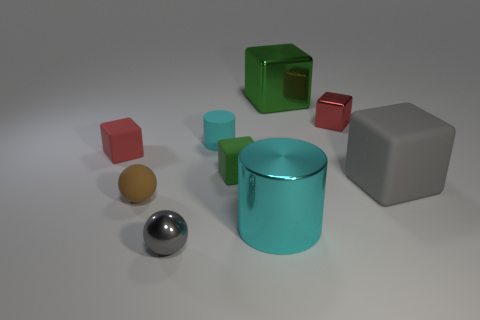There is a tiny shiny thing that is the same color as the big rubber object; what is its shape?
Make the answer very short. Sphere. What number of things are big cyan metallic cylinders or cyan cylinders in front of the small brown object?
Your answer should be compact. 1. What is the tiny cylinder made of?
Your answer should be very brief. Rubber. Are there any other things that are the same color as the large matte block?
Offer a very short reply. Yes. Does the red matte object have the same shape as the big green thing?
Ensure brevity in your answer.  Yes. What is the size of the cylinder behind the gray object that is right of the object that is in front of the cyan shiny cylinder?
Make the answer very short. Small. How many other objects are there of the same material as the big cyan object?
Your answer should be compact. 3. There is a metallic block that is behind the small metal cube; what is its color?
Keep it short and to the point. Green. There is a thing that is on the right side of the red block right of the gray object that is on the left side of the big cyan thing; what is it made of?
Keep it short and to the point. Rubber. Is there another cyan shiny object that has the same shape as the big cyan object?
Offer a terse response. No. 